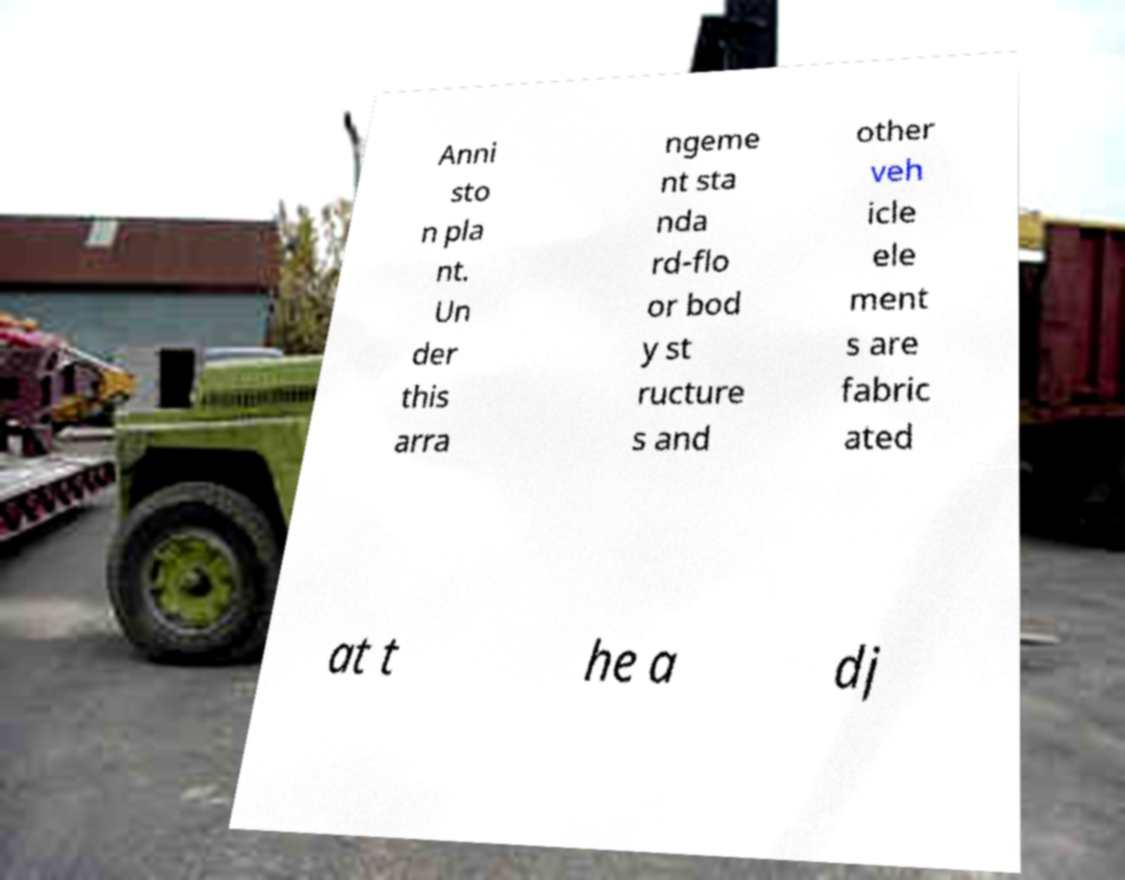Can you accurately transcribe the text from the provided image for me? Anni sto n pla nt. Un der this arra ngeme nt sta nda rd-flo or bod y st ructure s and other veh icle ele ment s are fabric ated at t he a dj 